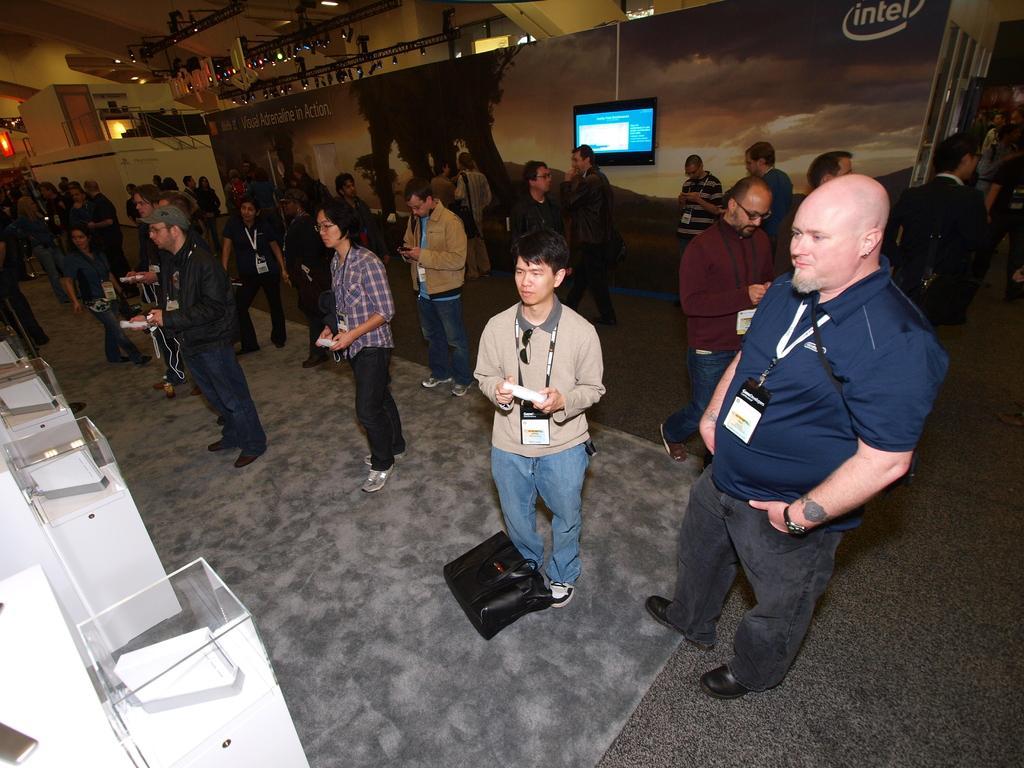In one or two sentences, can you explain what this image depicts? In the picture we can see some people are standing among them we can see some people are holding some objects. In the background we can see the wall and on the top of it we can see the lights. 